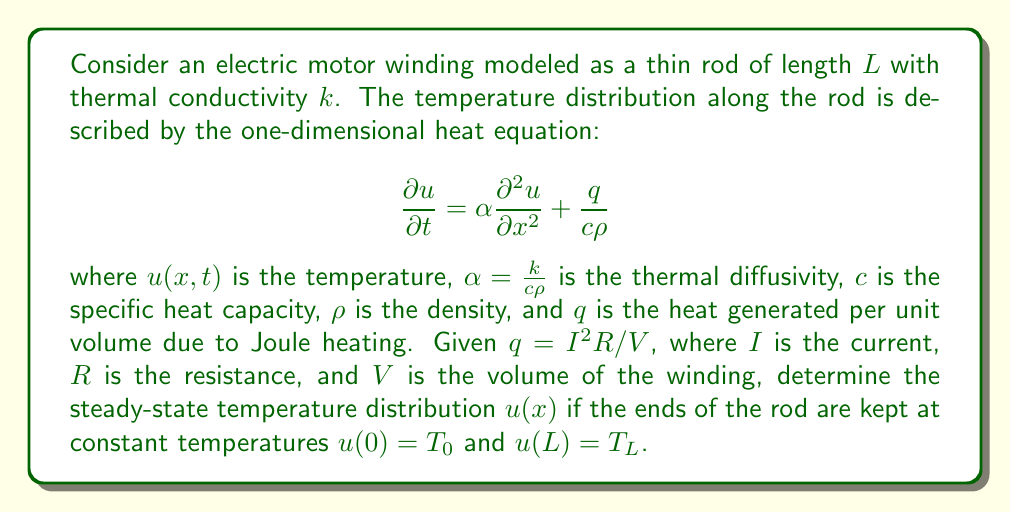Could you help me with this problem? To solve this problem, we'll follow these steps:

1) For the steady-state solution, $\frac{\partial u}{\partial t} = 0$, so the heat equation becomes:

   $$0 = \alpha \frac{d^2 u}{dx^2} + \frac{q}{c\rho}$$

2) Rearrange the equation:

   $$\frac{d^2 u}{dx^2} = -\frac{q}{k}$$

3) Integrate twice:

   $$\frac{du}{dx} = -\frac{q}{k}x + C_1$$
   $$u(x) = -\frac{q}{2k}x^2 + C_1x + C_2$$

4) Apply the boundary conditions:
   
   At $x = 0$: $u(0) = T_0 = C_2$
   At $x = L$: $u(L) = T_L = -\frac{q}{2k}L^2 + C_1L + T_0$

5) Solve for $C_1$:

   $$C_1 = \frac{T_L - T_0}{L} + \frac{qL}{2k}$$

6) Substitute back into the general solution:

   $$u(x) = -\frac{q}{2k}x^2 + (\frac{T_L - T_0}{L} + \frac{qL}{2k})x + T_0$$

7) Simplify:

   $$u(x) = \frac{q}{2k}(L-x)x + \frac{T_L - T_0}{L}x + T_0$$

This is the steady-state temperature distribution along the motor winding.
Answer: $u(x) = \frac{q}{2k}(L-x)x + \frac{T_L - T_0}{L}x + T_0$ 